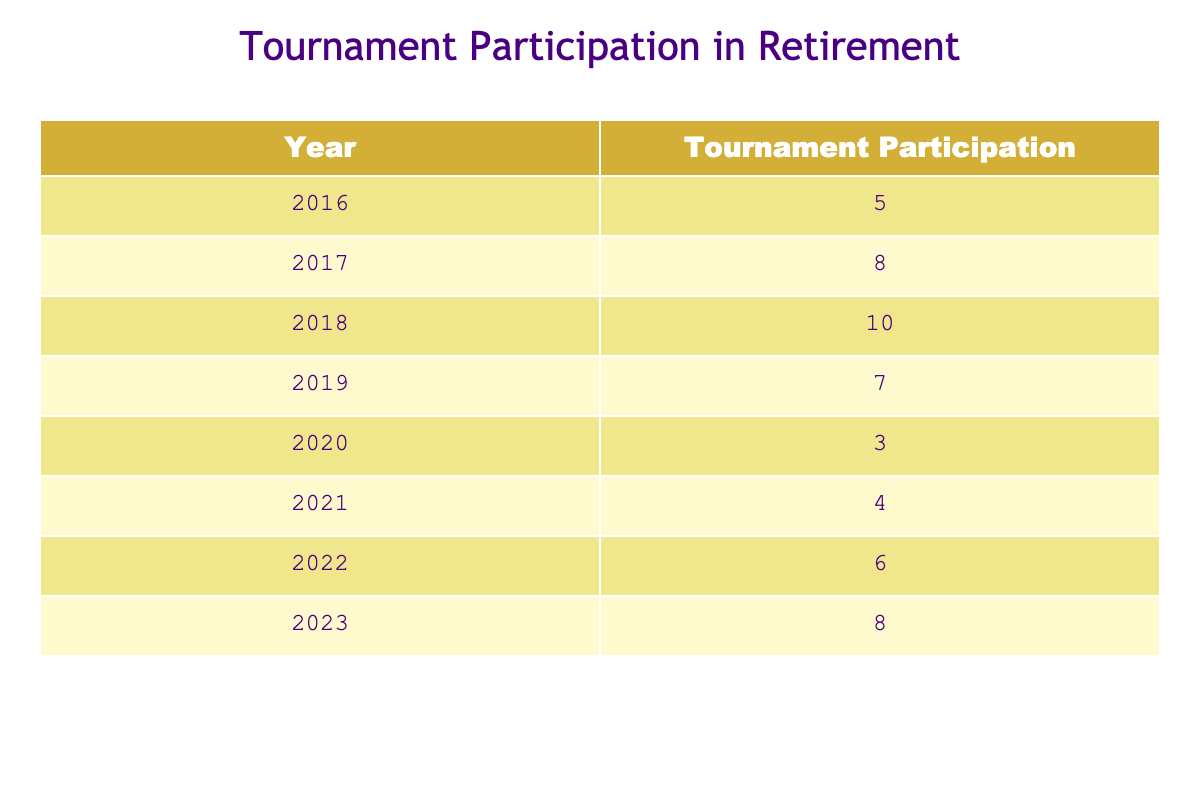What year had the highest tournament participation? By examining the "Tournament Participation" column, we can identify the year with the greatest value. Looking through the values, 2018 has the highest participation count of 10 tournaments.
Answer: 2018 What was the total number of tournaments participated in from 2016 to 2023? To find the total, we add the participation values for each year: 5 + 8 + 10 + 7 + 3 + 4 + 6 + 8 = 51.
Answer: 51 Did the tournament participation increase from 2019 to 2020? Comparing the values for these years, the participation in 2019 is 7 and in 2020 is 3. Since 3 is less than 7, the participation did not increase.
Answer: No What is the average number of tournaments participated in per year from 2016 to 2023? To calculate the average, we sum the participation values (51) and divide by the number of years (8): 51 / 8 = 6.375.
Answer: 6.375 Which year had the lowest number of tournaments participated in? Looking at the "Tournament Participation" column, 2020 has the lowest value of 3 tournaments.
Answer: 2020 What is the difference in tournament participation between 2018 and 2021? The participation values for 2018 and 2021 are 10 and 4 respectively. The difference is calculated as 10 - 4 = 6.
Answer: 6 Was there any year where tournament participation exceeded 8? Upon reviewing the values, 2018 with 10 and 2017 with 8 both qualify, indicating there were years with participation exceeding 8.
Answer: Yes If we exclude the year with the highest participation, what is the new average for the remaining years? Excluding 2018 (10 tournaments), we sum the remaining values (5 + 8 + 7 + 3 + 4 + 6 + 8 = 41) and divide by 7 years to get an average of 41 / 7 = 5.857.
Answer: 5.857 